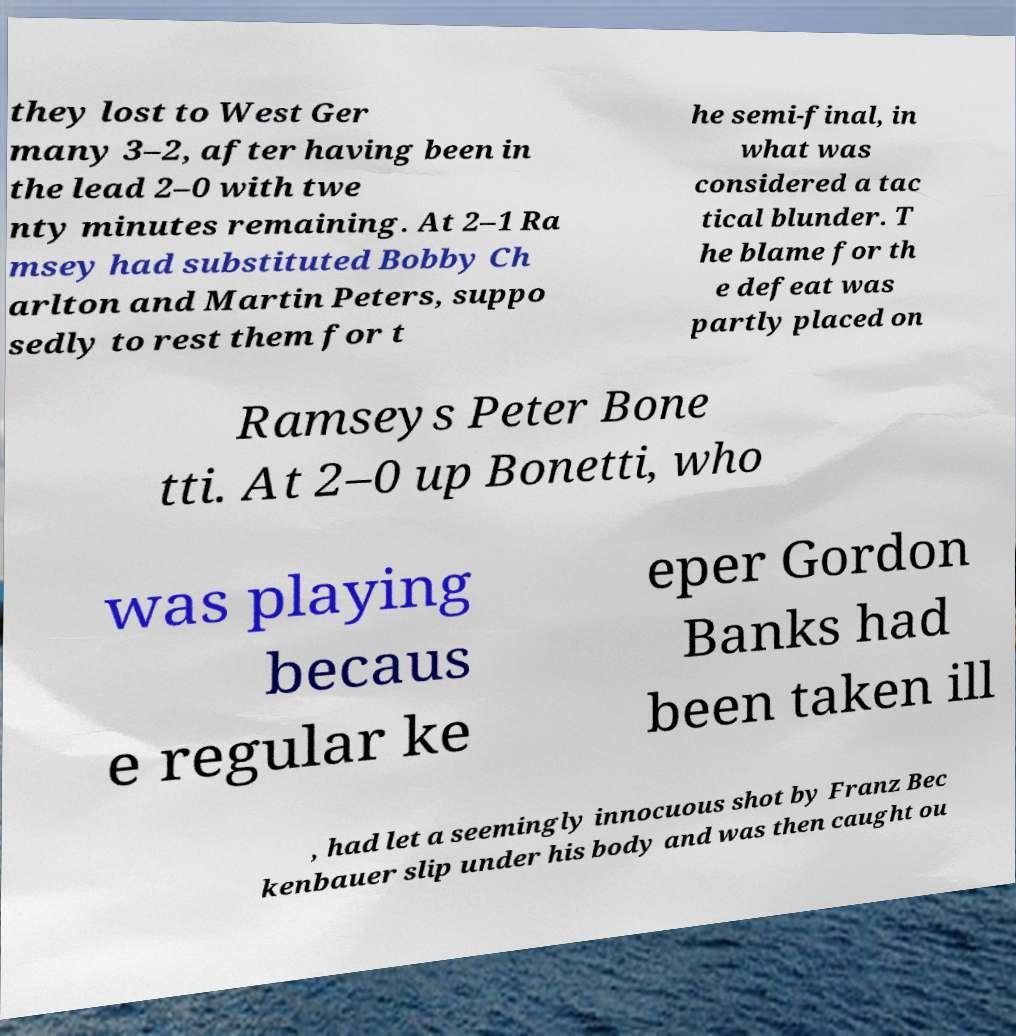Can you read and provide the text displayed in the image?This photo seems to have some interesting text. Can you extract and type it out for me? they lost to West Ger many 3–2, after having been in the lead 2–0 with twe nty minutes remaining. At 2–1 Ra msey had substituted Bobby Ch arlton and Martin Peters, suppo sedly to rest them for t he semi-final, in what was considered a tac tical blunder. T he blame for th e defeat was partly placed on Ramseys Peter Bone tti. At 2–0 up Bonetti, who was playing becaus e regular ke eper Gordon Banks had been taken ill , had let a seemingly innocuous shot by Franz Bec kenbauer slip under his body and was then caught ou 